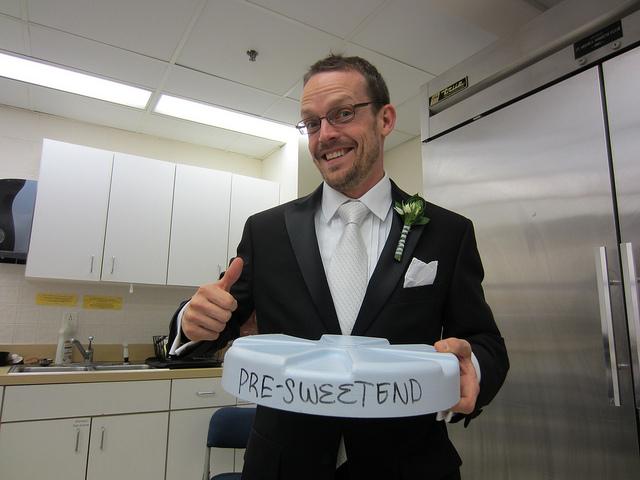What is on the man's lapel?
Write a very short answer. Flower. How many screws do you see?
Keep it brief. 0. What is the man holding?
Write a very short answer. Top. What color is his hair?
Keep it brief. Brown. What style facial hair is the man in the white shirt wearing?
Keep it brief. Goatee. How much money is the man holding?
Be succinct. 0. Do you think the man going to a party?
Keep it brief. Yes. What is the man signing?
Concise answer only. Happy birthday. 